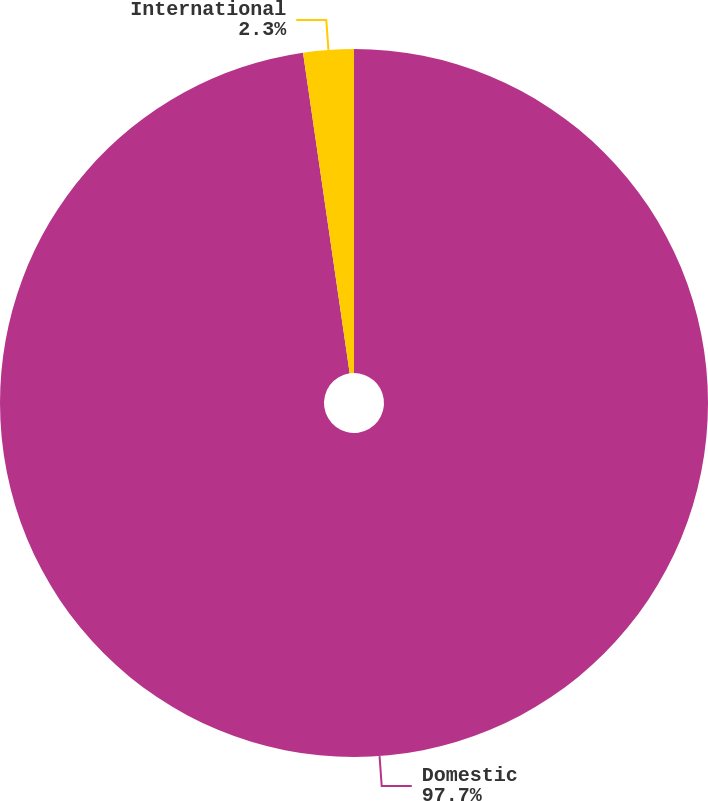Convert chart. <chart><loc_0><loc_0><loc_500><loc_500><pie_chart><fcel>Domestic<fcel>International<nl><fcel>97.7%<fcel>2.3%<nl></chart> 